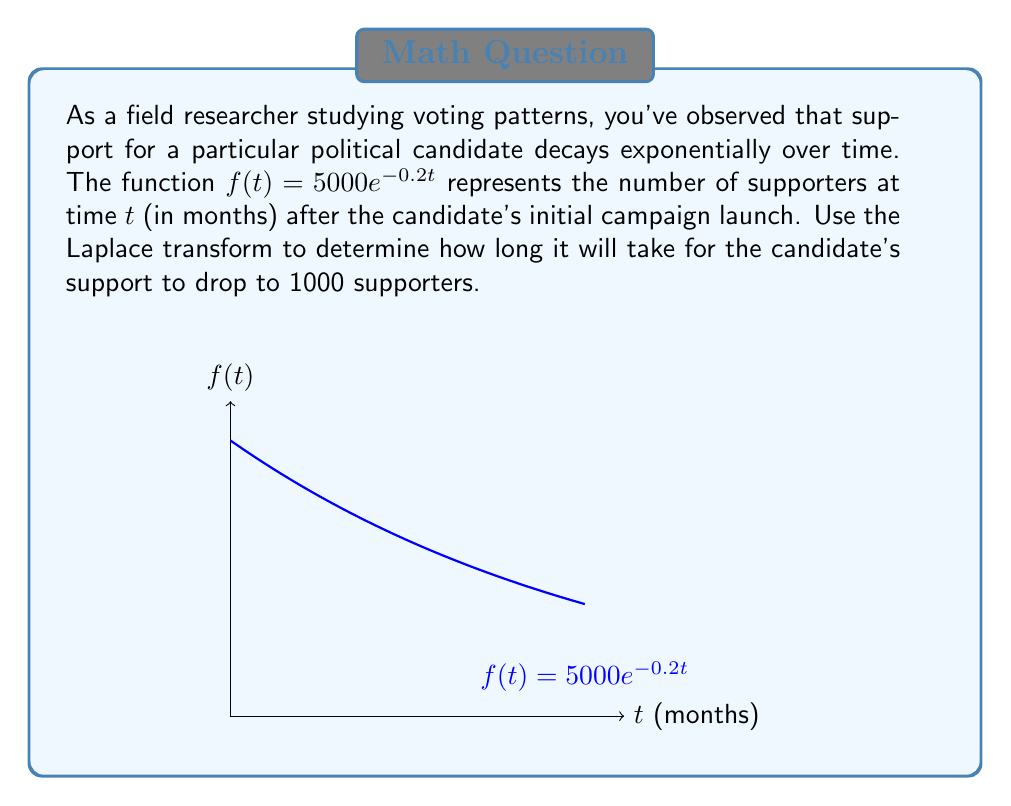Give your solution to this math problem. Let's approach this step-by-step using the Laplace transform:

1) We need to find $t$ when $f(t) = 1000$. This gives us the equation:
   $1000 = 5000e^{-0.2t}$

2) Divide both sides by 5000:
   $\frac{1}{5} = e^{-0.2t}$

3) Take the natural logarithm of both sides:
   $\ln(\frac{1}{5}) = -0.2t$

4) Solve for $t$:
   $t = -\frac{\ln(\frac{1}{5})}{0.2}$

5) Now, let's use the Laplace transform to verify this result. The Laplace transform of $f(t)$ is:
   $$\mathcal{L}\{f(t)\} = \mathcal{L}\{5000e^{-0.2t}\} = \frac{5000}{s+0.2}$$

6) To find when the function equals 1000, we need to solve:
   $$\frac{5000}{s+0.2} = \frac{1000}{s}$$

7) Cross-multiply:
   $5000s = 1000(s+0.2)$
   $5000s = 1000s + 200$
   $4000s = 200$
   $s = 0.05$

8) The time domain solution is:
   $t = -\frac{\ln(0.05)}{0.2} = \frac{\ln(20)}{0.2} \approx 14.98$ months

This confirms our algebraic solution from steps 1-4.
Answer: $\frac{\ln(20)}{0.2} \approx 14.98$ months 